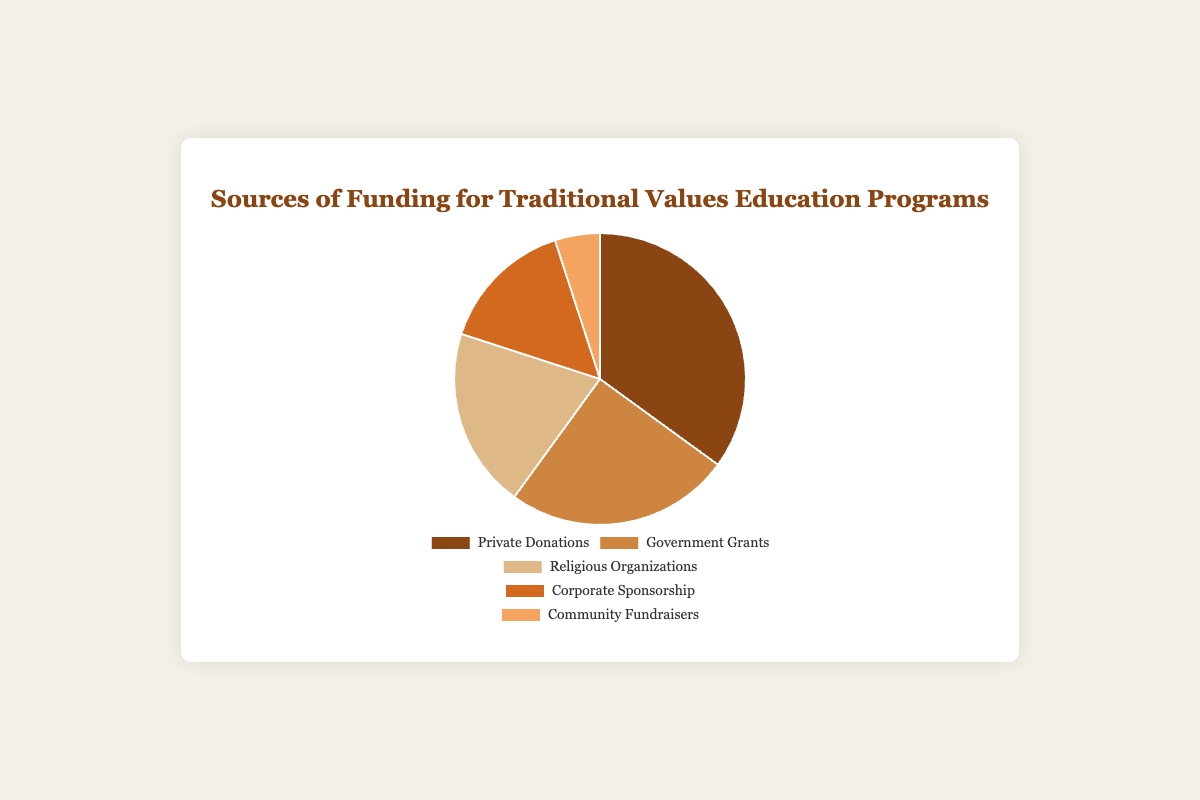What's the most significant source of funding for Traditional Values Education Programs? The pie chart depicts different sources of funding with Private Donations having the largest segment. By referring to the provided percentages, 35% of the total funding comes from Private Donations, which is higher than any other category.
Answer: Private Donations Which funding source contributes the least to Traditional Values Education Programs? Observing the chart, the smallest segment corresponds to Community Fundraisers, labeled with 5%. This portion is lower than all other funding sources.
Answer: Community Fundraisers What is the combined percentage of funding coming from Government Grants and Religious Organizations? Summing the percentages for Government Grants (25%) and Religious Organizations (20%) results in 25% + 20% = 45%. These two sources together contribute 45% of the funding.
Answer: 45% How does the percentage of Government Grants compare to Corporate Sponsorship in the funding distribution? Government Grants account for 25% of the funding, while Corporate Sponsorship contributes 15%. Therefore, Government Grants provide a greater portion of the funding than Corporate Sponsorship.
Answer: Government Grants provide a greater portion Which two funding sources are next to each other in terms of percentage contribution, excluding the largest and smallest contributors? Excluding the largest contributor (Private Donations at 35%) and the smallest contributor (Community Fundraisers at 5%), the next two closest in percentage are Government Grants (25%) and Religious Organizations (20%). Their percentages are 5% apart.
Answer: Government Grants and Religious Organizations Calculate the average funding percentage for all sources excluding the smallest contributor. We exclude Community Fundraisers (5%) and calculate the average of Private Donations (35%), Government Grants (25%), Religious Organizations (20%), and Corporate Sponsorship (15%). The total is 35 + 25 + 20 + 15 = 95. The average is 95/4 = 23.75%.
Answer: 23.75% Which source of funding is represented in a brownish color in the pie chart? Observing the color distinctions in the pie chart, Private Donations are presented in a prominent brownish color segment. The visual description here refers to hues matching the brown family.
Answer: Private Donations 